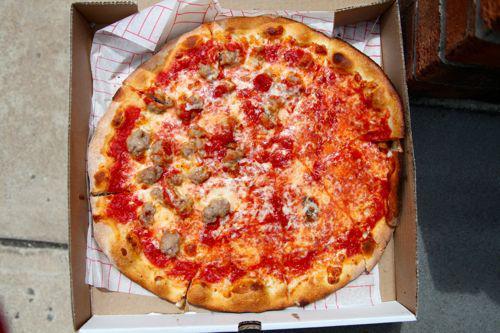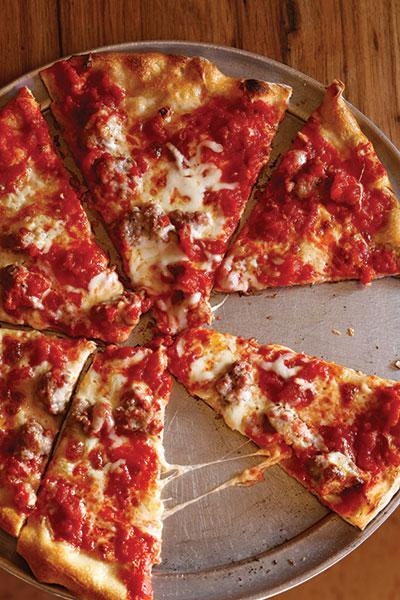The first image is the image on the left, the second image is the image on the right. For the images displayed, is the sentence "Each image shows a pizza with no slices removed, and one image features a pizza topped with round tomato slices and a green leafy garnish." factually correct? Answer yes or no. No. The first image is the image on the left, the second image is the image on the right. Evaluate the accuracy of this statement regarding the images: "Large slices of tomato sit on top of a pizza.". Is it true? Answer yes or no. No. 